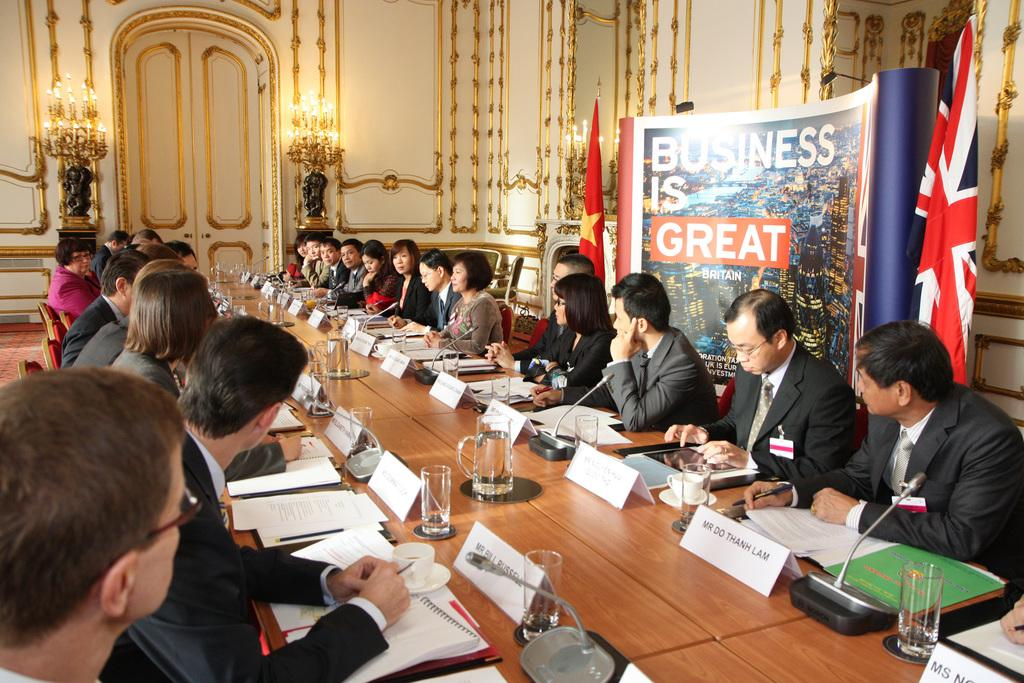What are the people in the image doing? The people in the image are sitting on chairs. What is present in the image besides the people? There is a table in the image. What is on the table in the image? There are papers and glasses on the table. What type of fuel is being used by the people in the image? There is no mention of fuel in the image, as it features people sitting on chairs and a table with papers and glasses. 